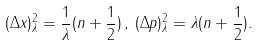<formula> <loc_0><loc_0><loc_500><loc_500>( \Delta x ) ^ { 2 } _ { \lambda } = \frac { 1 } { \lambda } ( n + \frac { 1 } { 2 } ) \, , \, ( \Delta p ) ^ { 2 } _ { \lambda } = \lambda ( n + \frac { 1 } { 2 } ) .</formula> 